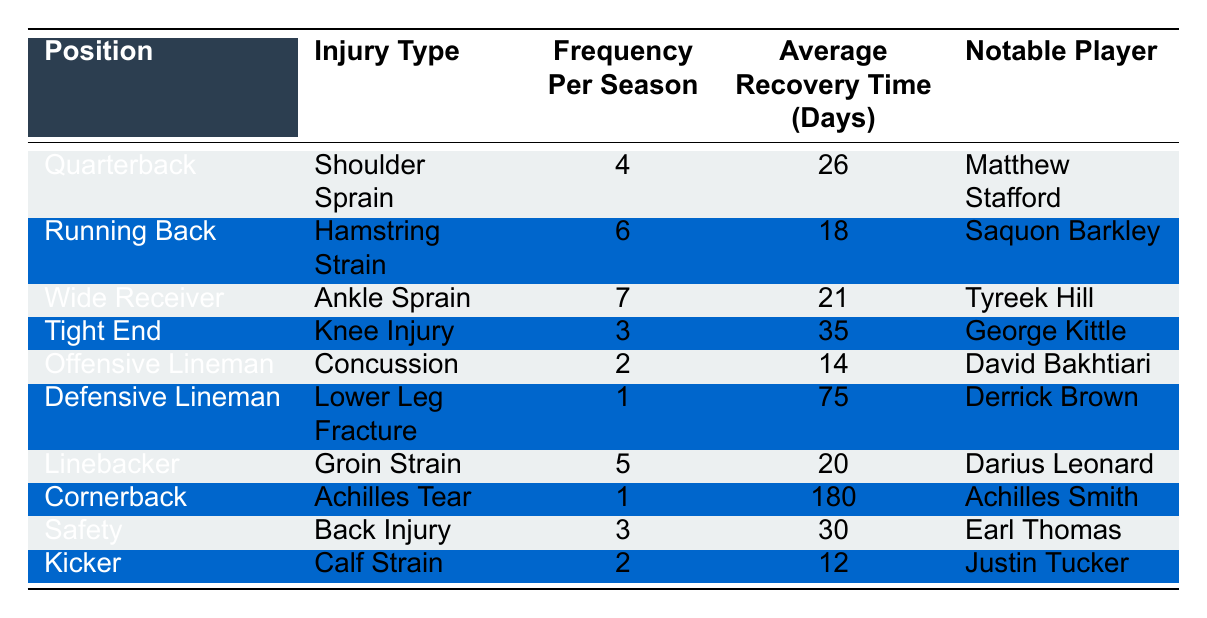What is the injury type most frequently seen for Wide Receivers? According to the table, Wide Receivers primarily suffer from Ankle Sprains, which are listed as the injury type for this position.
Answer: Ankle Sprain Which position has the highest average recovery time? By analyzing the average recovery times, the Cornerback position has the longest recovery time due to the Achilles Tear, which takes 180 days.
Answer: Cornerback How many injuries do Running Backs have on average per season, according to the data? The data indicates that Running Backs have a frequency of 6 injuries per season as listed in the corresponding row of the table.
Answer: 6 What is the average recovery time for Defensive Linemen? The table shows that Defensive Linemen have an average recovery time of 75 days for Lower Leg Fractures.
Answer: 75 days Is it true that Tight Ends have a higher frequency of injuries than Offensive Linemen? Comparing the frequency of injuries, Tight Ends have 3 injuries while Offensive Linemen have 2 injuries, confirming that Tight Ends have a higher frequency.
Answer: Yes What is the total frequency of injuries for all positions combined? To find the total, we sum the frequency per season from all positions: 4 (Quarterback) + 6 (Running Back) + 7 (Wide Receiver) + 3 (Tight End) + 2 (Offensive Lineman) + 1 (Defensive Lineman) + 5 (Linebacker) + 1 (Cornerback) + 3 (Safety) + 2 (Kicker) = 34.
Answer: 34 Which position has the lowest injury frequency? The position with the lowest frequency of injuries is the Defensive Lineman, with a frequency of just 1 injury per season.
Answer: Defensive Lineman What is the average recovery time for players who suffer from hamstring strains? The table indicates that Running Backs suffer from Hamstring Strains, and their average recovery time is 18 days, which represents the average recovery time for this injury type.
Answer: 18 days Are all kicker injuries less severe than those for Wide Receivers based on average recovery times? The average recovery time for Kicker injuries (12 days for Calf Strain) is lower than that for Wide Receiver injuries (21 days for Ankle Sprain), indicating that Kicker injuries are less severe.
Answer: Yes Calculate the average recovery time across all positions listed. The average recovery time can be calculated by summing the recovery times: (26 + 18 + 21 + 35 + 14 + 75 + 20 + 180 + 30 + 12) =  421 days. Then, divide by the number of positions (10): 421 / 10 = 42.1 days.
Answer: 42.1 days 